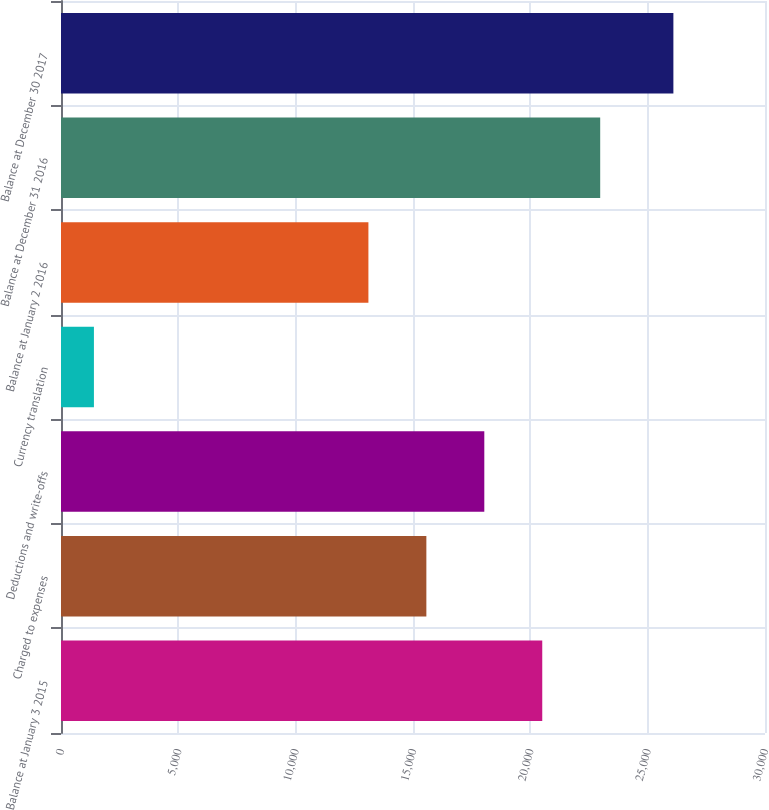Convert chart. <chart><loc_0><loc_0><loc_500><loc_500><bar_chart><fcel>Balance at January 3 2015<fcel>Charged to expenses<fcel>Deductions and write-offs<fcel>Currency translation<fcel>Balance at January 2 2016<fcel>Balance at December 31 2016<fcel>Balance at December 30 2017<nl><fcel>20507.9<fcel>15569.3<fcel>18038.6<fcel>1403<fcel>13100<fcel>22977.2<fcel>26096<nl></chart> 